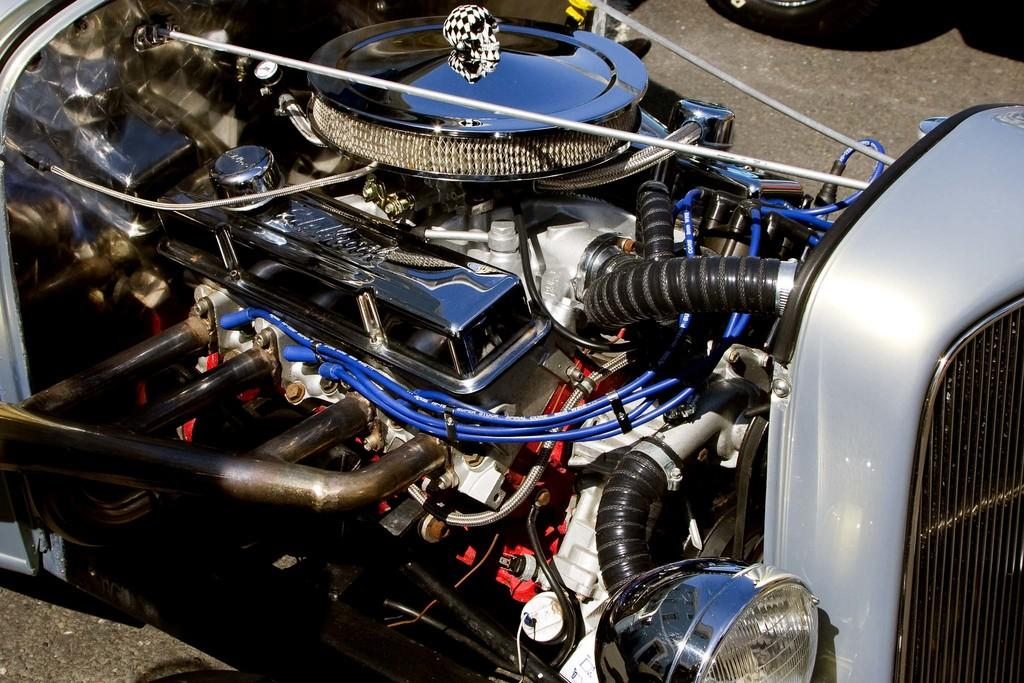What is the main subject of the image? The main subject of the image is a part of a car engine. Can you describe the part of the car engine in more detail? Unfortunately, the facts provided do not give any specific details about the part of the car engine. What type of vehicle does this part belong to? The facts provided do not specify which type of vehicle the car engine part belongs to. What letter is written on the roof of the car in the image? There is no car or roof present in the image; it only features a part of a car engine. 